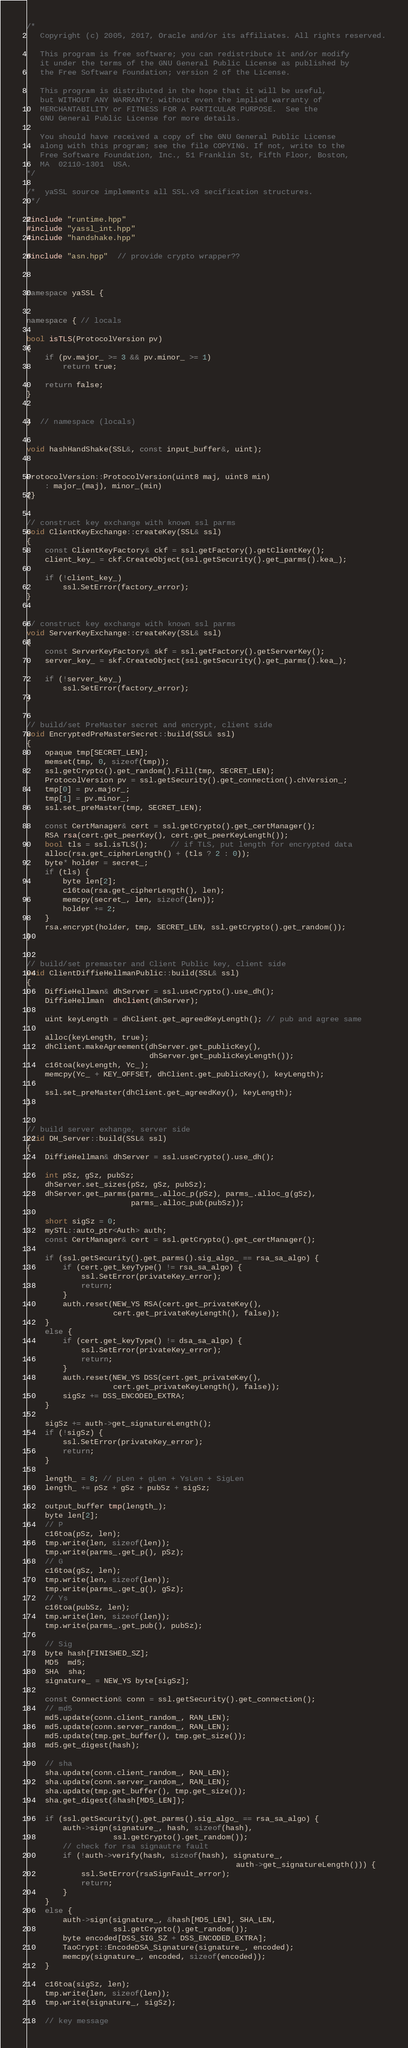<code> <loc_0><loc_0><loc_500><loc_500><_C++_>/*
   Copyright (c) 2005, 2017, Oracle and/or its affiliates. All rights reserved.

   This program is free software; you can redistribute it and/or modify
   it under the terms of the GNU General Public License as published by
   the Free Software Foundation; version 2 of the License.

   This program is distributed in the hope that it will be useful,
   but WITHOUT ANY WARRANTY; without even the implied warranty of
   MERCHANTABILITY or FITNESS FOR A PARTICULAR PURPOSE.  See the
   GNU General Public License for more details.

   You should have received a copy of the GNU General Public License
   along with this program; see the file COPYING. If not, write to the
   Free Software Foundation, Inc., 51 Franklin St, Fifth Floor, Boston,
   MA  02110-1301  USA.
*/

/*  yaSSL source implements all SSL.v3 secification structures.
 */

#include "runtime.hpp"
#include "yassl_int.hpp"
#include "handshake.hpp"

#include "asn.hpp"  // provide crypto wrapper??



namespace yaSSL {


namespace { // locals

bool isTLS(ProtocolVersion pv)
{
    if (pv.major_ >= 3 && pv.minor_ >= 1)
        return true;

    return false;
}


}  // namespace (locals)


void hashHandShake(SSL&, const input_buffer&, uint);


ProtocolVersion::ProtocolVersion(uint8 maj, uint8 min) 
    : major_(maj), minor_(min) 
{}


// construct key exchange with known ssl parms
void ClientKeyExchange::createKey(SSL& ssl)
{
    const ClientKeyFactory& ckf = ssl.getFactory().getClientKey();
    client_key_ = ckf.CreateObject(ssl.getSecurity().get_parms().kea_);

    if (!client_key_)
        ssl.SetError(factory_error);
}


// construct key exchange with known ssl parms
void ServerKeyExchange::createKey(SSL& ssl)
{
    const ServerKeyFactory& skf = ssl.getFactory().getServerKey();
    server_key_ = skf.CreateObject(ssl.getSecurity().get_parms().kea_);

    if (!server_key_)
        ssl.SetError(factory_error);
}


// build/set PreMaster secret and encrypt, client side
void EncryptedPreMasterSecret::build(SSL& ssl)
{
    opaque tmp[SECRET_LEN];
    memset(tmp, 0, sizeof(tmp));
    ssl.getCrypto().get_random().Fill(tmp, SECRET_LEN);
    ProtocolVersion pv = ssl.getSecurity().get_connection().chVersion_;
    tmp[0] = pv.major_;
    tmp[1] = pv.minor_;
    ssl.set_preMaster(tmp, SECRET_LEN);

    const CertManager& cert = ssl.getCrypto().get_certManager();
    RSA rsa(cert.get_peerKey(), cert.get_peerKeyLength());
    bool tls = ssl.isTLS();     // if TLS, put length for encrypted data
    alloc(rsa.get_cipherLength() + (tls ? 2 : 0));
    byte* holder = secret_;
    if (tls) {
        byte len[2];
        c16toa(rsa.get_cipherLength(), len);
        memcpy(secret_, len, sizeof(len));
        holder += 2;
    }
    rsa.encrypt(holder, tmp, SECRET_LEN, ssl.getCrypto().get_random());
}


// build/set premaster and Client Public key, client side
void ClientDiffieHellmanPublic::build(SSL& ssl)
{
    DiffieHellman& dhServer = ssl.useCrypto().use_dh();
    DiffieHellman  dhClient(dhServer);

    uint keyLength = dhClient.get_agreedKeyLength(); // pub and agree same

    alloc(keyLength, true);
    dhClient.makeAgreement(dhServer.get_publicKey(),
                           dhServer.get_publicKeyLength());
    c16toa(keyLength, Yc_);
    memcpy(Yc_ + KEY_OFFSET, dhClient.get_publicKey(), keyLength);

    ssl.set_preMaster(dhClient.get_agreedKey(), keyLength);
}


// build server exhange, server side
void DH_Server::build(SSL& ssl)
{
    DiffieHellman& dhServer = ssl.useCrypto().use_dh();

    int pSz, gSz, pubSz;
    dhServer.set_sizes(pSz, gSz, pubSz);
    dhServer.get_parms(parms_.alloc_p(pSz), parms_.alloc_g(gSz),
                       parms_.alloc_pub(pubSz));

    short sigSz = 0;
    mySTL::auto_ptr<Auth> auth;
    const CertManager& cert = ssl.getCrypto().get_certManager();
    
    if (ssl.getSecurity().get_parms().sig_algo_ == rsa_sa_algo) {
        if (cert.get_keyType() != rsa_sa_algo) {
            ssl.SetError(privateKey_error);
            return;
        }
        auth.reset(NEW_YS RSA(cert.get_privateKey(),
                   cert.get_privateKeyLength(), false));
    }
    else {
        if (cert.get_keyType() != dsa_sa_algo) {
            ssl.SetError(privateKey_error);
            return;
        }
        auth.reset(NEW_YS DSS(cert.get_privateKey(),
                   cert.get_privateKeyLength(), false));
        sigSz += DSS_ENCODED_EXTRA;
    }
    
    sigSz += auth->get_signatureLength();
    if (!sigSz) {
        ssl.SetError(privateKey_error);
        return;
    }

    length_ = 8; // pLen + gLen + YsLen + SigLen
    length_ += pSz + gSz + pubSz + sigSz;

    output_buffer tmp(length_);
    byte len[2];
    // P
    c16toa(pSz, len);
    tmp.write(len, sizeof(len));
    tmp.write(parms_.get_p(), pSz);
    // G
    c16toa(gSz, len);
    tmp.write(len, sizeof(len));
    tmp.write(parms_.get_g(), gSz);
    // Ys
    c16toa(pubSz, len);
    tmp.write(len, sizeof(len));
    tmp.write(parms_.get_pub(), pubSz);

    // Sig
    byte hash[FINISHED_SZ];
    MD5  md5;
    SHA  sha;
    signature_ = NEW_YS byte[sigSz];

    const Connection& conn = ssl.getSecurity().get_connection();
    // md5
    md5.update(conn.client_random_, RAN_LEN);
    md5.update(conn.server_random_, RAN_LEN);
    md5.update(tmp.get_buffer(), tmp.get_size());
    md5.get_digest(hash);

    // sha
    sha.update(conn.client_random_, RAN_LEN);
    sha.update(conn.server_random_, RAN_LEN);
    sha.update(tmp.get_buffer(), tmp.get_size());
    sha.get_digest(&hash[MD5_LEN]);

    if (ssl.getSecurity().get_parms().sig_algo_ == rsa_sa_algo) {
        auth->sign(signature_, hash, sizeof(hash),
                   ssl.getCrypto().get_random());
        // check for rsa signautre fault
        if (!auth->verify(hash, sizeof(hash), signature_,
                                              auth->get_signatureLength())) {
            ssl.SetError(rsaSignFault_error);
            return;
        }
    }
    else {
        auth->sign(signature_, &hash[MD5_LEN], SHA_LEN,
                   ssl.getCrypto().get_random());
        byte encoded[DSS_SIG_SZ + DSS_ENCODED_EXTRA];
        TaoCrypt::EncodeDSA_Signature(signature_, encoded);
        memcpy(signature_, encoded, sizeof(encoded));
    }

    c16toa(sigSz, len);
    tmp.write(len, sizeof(len));
    tmp.write(signature_, sigSz);

    // key message</code> 